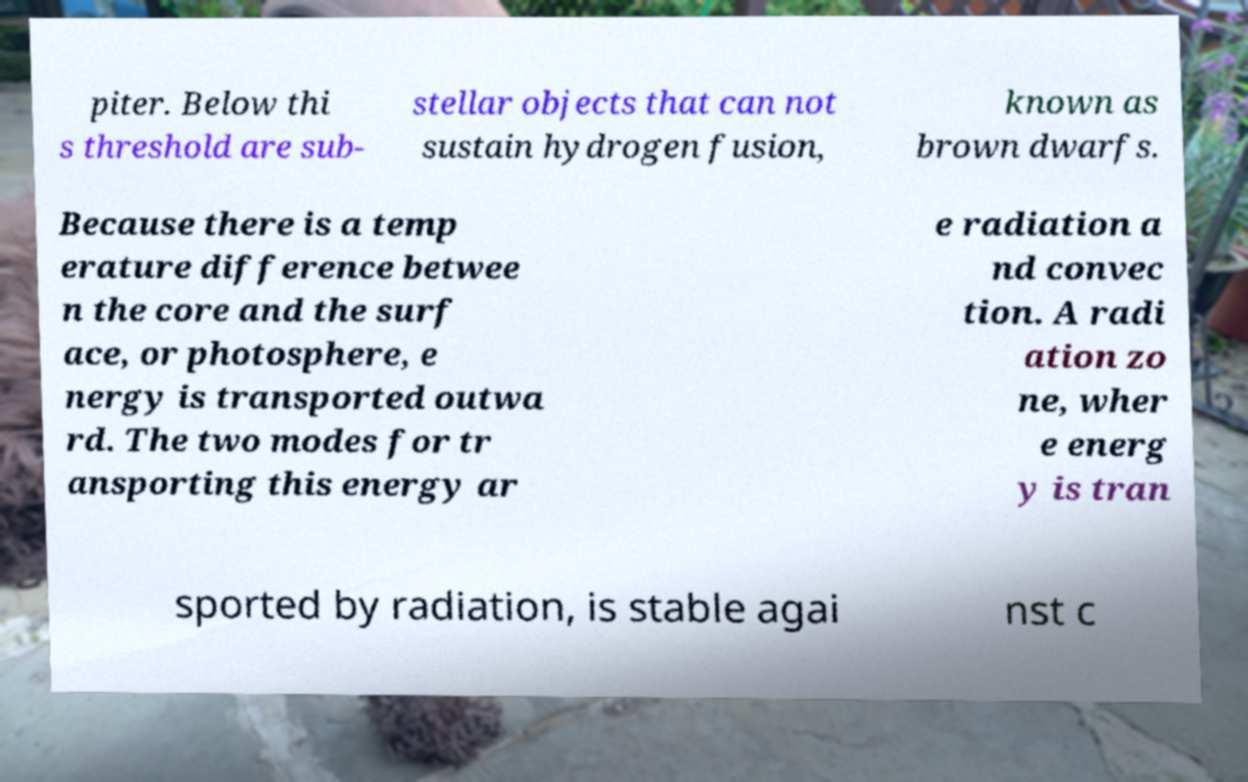What messages or text are displayed in this image? I need them in a readable, typed format. piter. Below thi s threshold are sub- stellar objects that can not sustain hydrogen fusion, known as brown dwarfs. Because there is a temp erature difference betwee n the core and the surf ace, or photosphere, e nergy is transported outwa rd. The two modes for tr ansporting this energy ar e radiation a nd convec tion. A radi ation zo ne, wher e energ y is tran sported by radiation, is stable agai nst c 